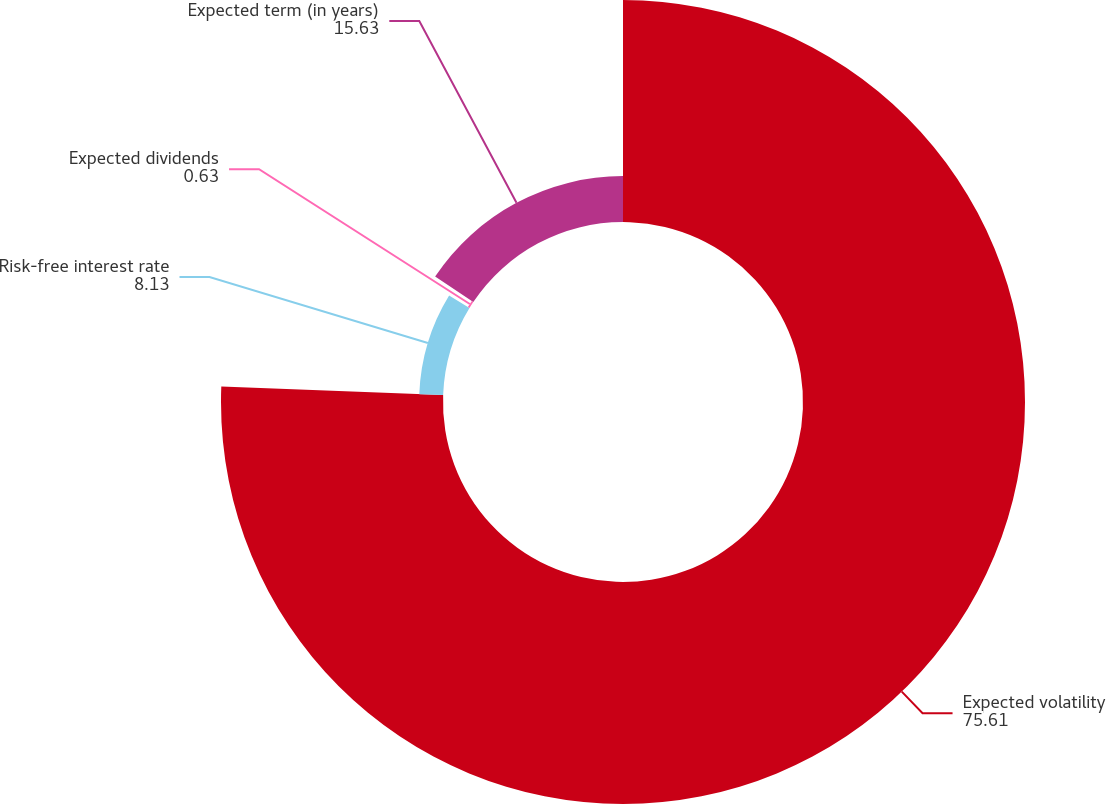Convert chart. <chart><loc_0><loc_0><loc_500><loc_500><pie_chart><fcel>Expected volatility<fcel>Risk-free interest rate<fcel>Expected dividends<fcel>Expected term (in years)<nl><fcel>75.61%<fcel>8.13%<fcel>0.63%<fcel>15.63%<nl></chart> 